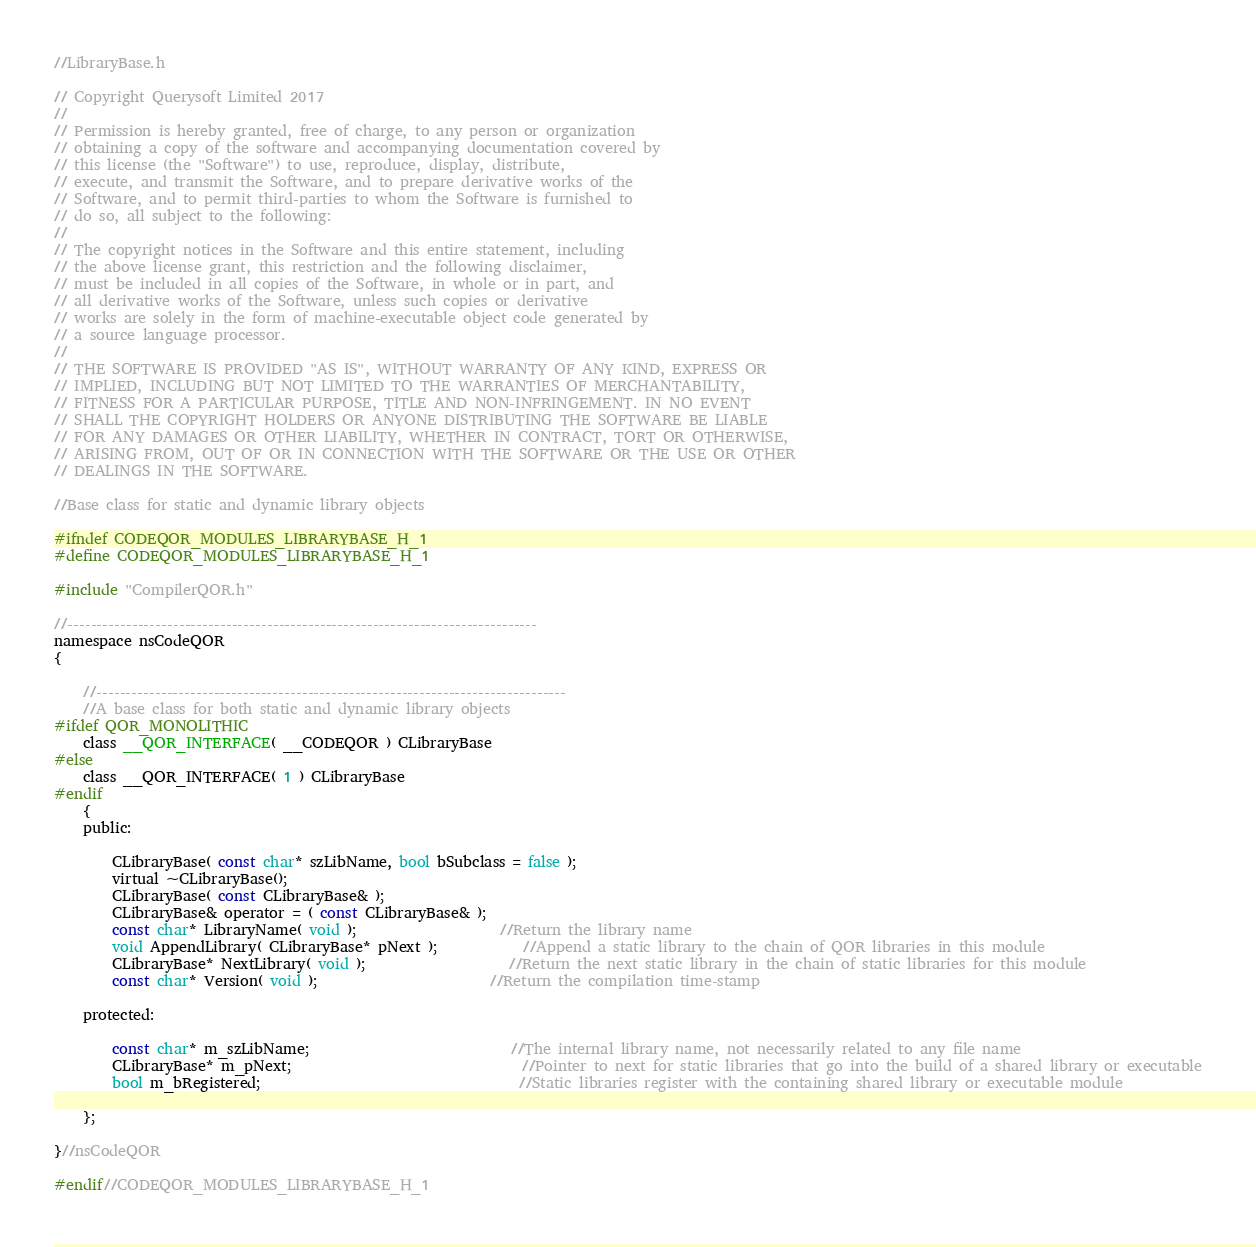<code> <loc_0><loc_0><loc_500><loc_500><_C_>//LibraryBase.h

// Copyright Querysoft Limited 2017
//
// Permission is hereby granted, free of charge, to any person or organization
// obtaining a copy of the software and accompanying documentation covered by
// this license (the "Software") to use, reproduce, display, distribute,
// execute, and transmit the Software, and to prepare derivative works of the
// Software, and to permit third-parties to whom the Software is furnished to
// do so, all subject to the following:
//
// The copyright notices in the Software and this entire statement, including
// the above license grant, this restriction and the following disclaimer,
// must be included in all copies of the Software, in whole or in part, and
// all derivative works of the Software, unless such copies or derivative
// works are solely in the form of machine-executable object code generated by
// a source language processor.
//
// THE SOFTWARE IS PROVIDED "AS IS", WITHOUT WARRANTY OF ANY KIND, EXPRESS OR
// IMPLIED, INCLUDING BUT NOT LIMITED TO THE WARRANTIES OF MERCHANTABILITY,
// FITNESS FOR A PARTICULAR PURPOSE, TITLE AND NON-INFRINGEMENT. IN NO EVENT
// SHALL THE COPYRIGHT HOLDERS OR ANYONE DISTRIBUTING THE SOFTWARE BE LIABLE
// FOR ANY DAMAGES OR OTHER LIABILITY, WHETHER IN CONTRACT, TORT OR OTHERWISE,
// ARISING FROM, OUT OF OR IN CONNECTION WITH THE SOFTWARE OR THE USE OR OTHER
// DEALINGS IN THE SOFTWARE.

//Base class for static and dynamic library objects

#ifndef CODEQOR_MODULES_LIBRARYBASE_H_1
#define CODEQOR_MODULES_LIBRARYBASE_H_1

#include "CompilerQOR.h"

//--------------------------------------------------------------------------------
namespace nsCodeQOR
{

    //--------------------------------------------------------------------------------
	//A base class for both static and dynamic library objects
#ifdef QOR_MONOLITHIC
	class __QOR_INTERFACE( __CODEQOR ) CLibraryBase
#else
	class __QOR_INTERFACE( 1 ) CLibraryBase
#endif
    {
    public:

        CLibraryBase( const char* szLibName, bool bSubclass = false );
        virtual ~CLibraryBase();
		CLibraryBase( const CLibraryBase& );
		CLibraryBase& operator = ( const CLibraryBase& );
		const char* LibraryName( void );					//Return the library name
		void AppendLibrary( CLibraryBase* pNext );			//Append a static library to the chain of QOR libraries in this module
		CLibraryBase* NextLibrary( void );					//Return the next static library in the chain of static libraries for this module
		const char* Version( void );						//Return the compilation time-stamp

	protected:

		const char* m_szLibName;							//The internal library name, not necessarily related to any file name
		CLibraryBase* m_pNext;								//Pointer to next for static libraries that go into the build of a shared library or executable
		bool m_bRegistered;									//Static libraries register with the containing shared library or executable module

    };

}//nsCodeQOR

#endif//CODEQOR_MODULES_LIBRARYBASE_H_1
</code> 